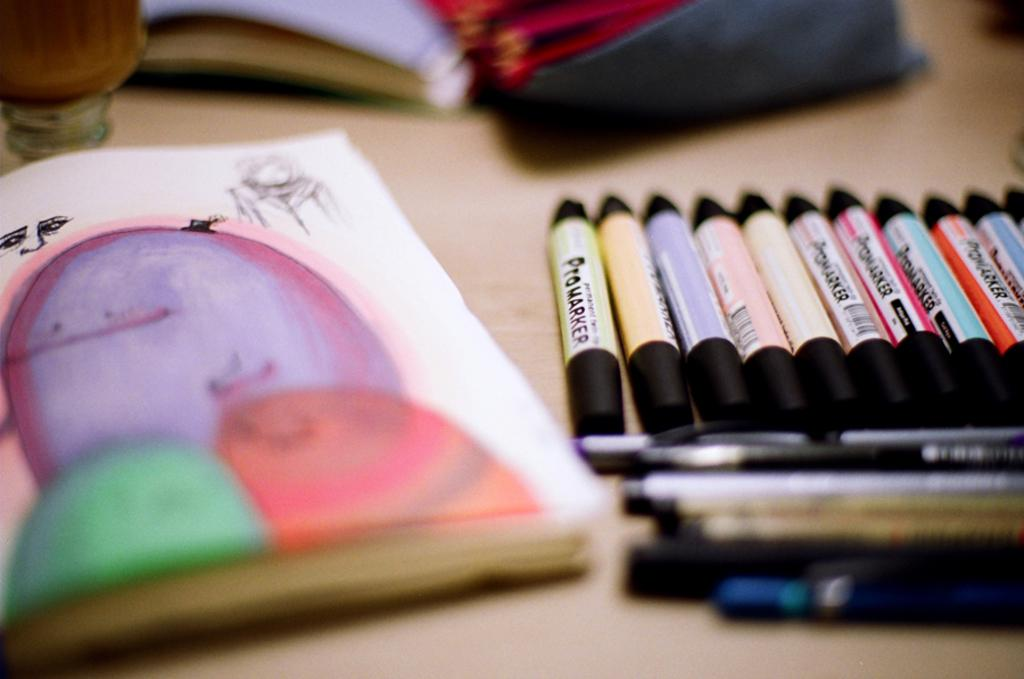<image>
Offer a succinct explanation of the picture presented. A group of artist materials, included ProMarker pencils in different colors. 